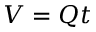Convert formula to latex. <formula><loc_0><loc_0><loc_500><loc_500>V = Q t</formula> 